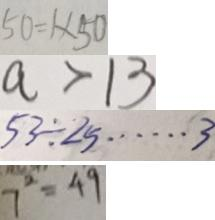Convert formula to latex. <formula><loc_0><loc_0><loc_500><loc_500>5 0 = 1 \times 5 0 
 a > 1 3 
 5 3 \div 2 5 \cdots 3 
 7 ^ { 2 } = 4 9</formula> 